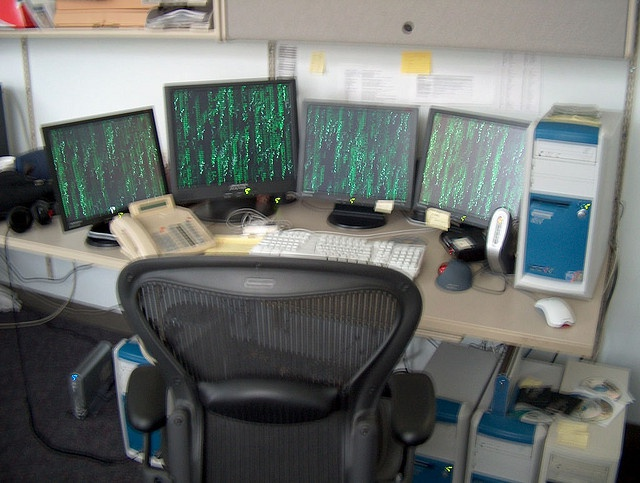Describe the objects in this image and their specific colors. I can see chair in brown, black, and gray tones, tv in brown, gray, darkgray, teal, and black tones, tv in brown, teal, black, gray, and darkgreen tones, tv in brown, gray, teal, and darkgray tones, and keyboard in brown, lightgray, darkgray, and gray tones in this image. 